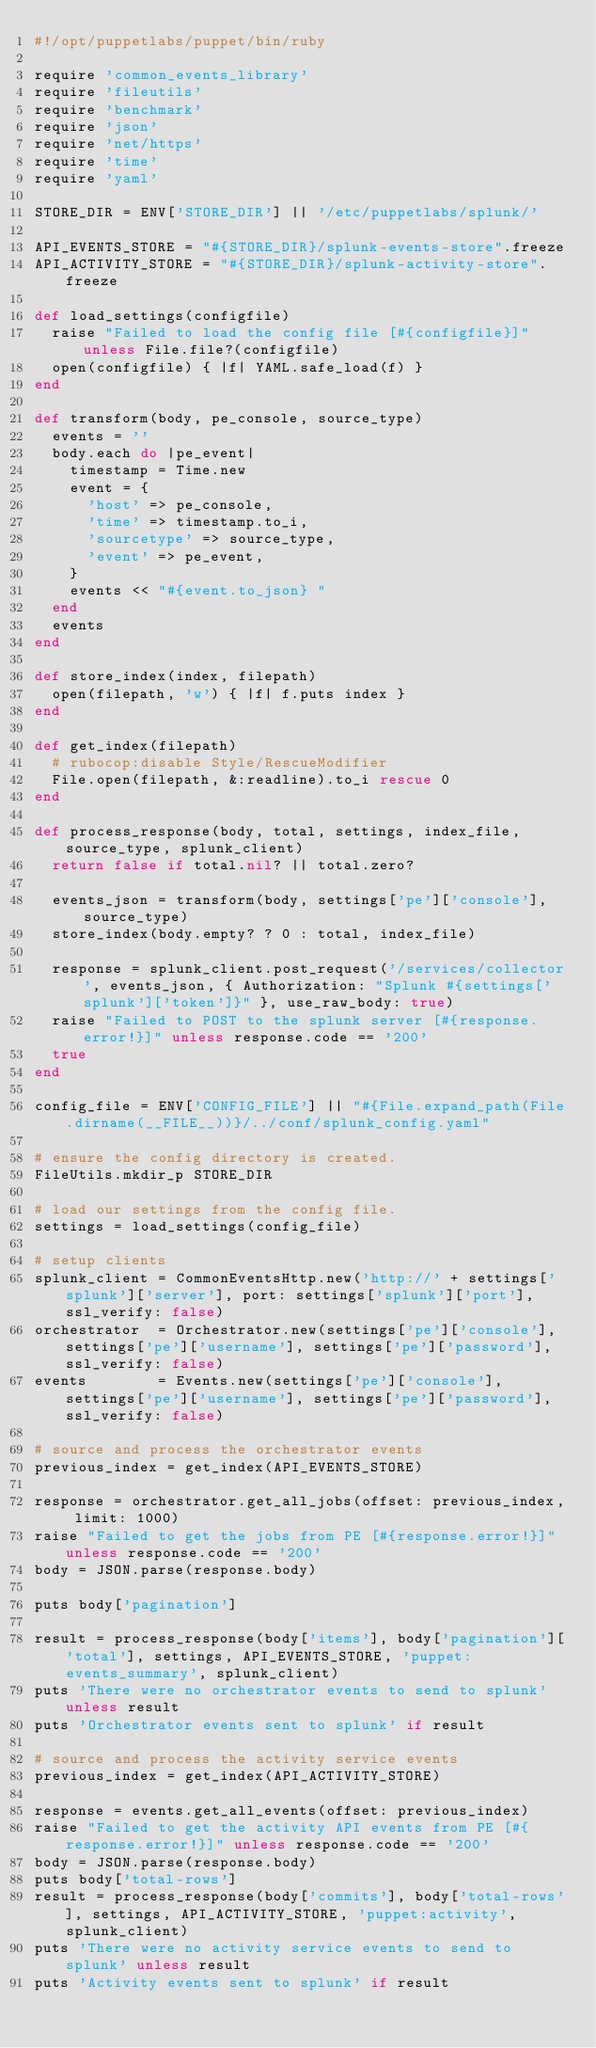<code> <loc_0><loc_0><loc_500><loc_500><_Ruby_>#!/opt/puppetlabs/puppet/bin/ruby

require 'common_events_library'
require 'fileutils'
require 'benchmark'
require 'json'
require 'net/https'
require 'time'
require 'yaml'

STORE_DIR = ENV['STORE_DIR'] || '/etc/puppetlabs/splunk/'

API_EVENTS_STORE = "#{STORE_DIR}/splunk-events-store".freeze
API_ACTIVITY_STORE = "#{STORE_DIR}/splunk-activity-store".freeze

def load_settings(configfile)
  raise "Failed to load the config file [#{configfile}]" unless File.file?(configfile)
  open(configfile) { |f| YAML.safe_load(f) }
end

def transform(body, pe_console, source_type)
  events = ''
  body.each do |pe_event|
    timestamp = Time.new
    event = {
      'host' => pe_console,
      'time' => timestamp.to_i,
      'sourcetype' => source_type,
      'event' => pe_event,
    }
    events << "#{event.to_json} "
  end
  events
end

def store_index(index, filepath)
  open(filepath, 'w') { |f| f.puts index }
end

def get_index(filepath)
  # rubocop:disable Style/RescueModifier
  File.open(filepath, &:readline).to_i rescue 0
end

def process_response(body, total, settings, index_file, source_type, splunk_client)
  return false if total.nil? || total.zero?

  events_json = transform(body, settings['pe']['console'], source_type)
  store_index(body.empty? ? 0 : total, index_file)

  response = splunk_client.post_request('/services/collector', events_json, { Authorization: "Splunk #{settings['splunk']['token']}" }, use_raw_body: true)
  raise "Failed to POST to the splunk server [#{response.error!}]" unless response.code == '200'
  true
end

config_file = ENV['CONFIG_FILE'] || "#{File.expand_path(File.dirname(__FILE__))}/../conf/splunk_config.yaml"

# ensure the config directory is created.
FileUtils.mkdir_p STORE_DIR

# load our settings from the config file.
settings = load_settings(config_file)

# setup clients
splunk_client = CommonEventsHttp.new('http://' + settings['splunk']['server'], port: settings['splunk']['port'], ssl_verify: false)
orchestrator  = Orchestrator.new(settings['pe']['console'], settings['pe']['username'], settings['pe']['password'], ssl_verify: false)
events        = Events.new(settings['pe']['console'], settings['pe']['username'], settings['pe']['password'], ssl_verify: false)

# source and process the orchestrator events
previous_index = get_index(API_EVENTS_STORE)

response = orchestrator.get_all_jobs(offset: previous_index, limit: 1000)
raise "Failed to get the jobs from PE [#{response.error!}]" unless response.code == '200'
body = JSON.parse(response.body)

puts body['pagination']

result = process_response(body['items'], body['pagination']['total'], settings, API_EVENTS_STORE, 'puppet:events_summary', splunk_client)
puts 'There were no orchestrator events to send to splunk' unless result
puts 'Orchestrator events sent to splunk' if result

# source and process the activity service events
previous_index = get_index(API_ACTIVITY_STORE)

response = events.get_all_events(offset: previous_index)
raise "Failed to get the activity API events from PE [#{response.error!}]" unless response.code == '200'
body = JSON.parse(response.body)
puts body['total-rows']
result = process_response(body['commits'], body['total-rows'], settings, API_ACTIVITY_STORE, 'puppet:activity', splunk_client)
puts 'There were no activity service events to send to splunk' unless result
puts 'Activity events sent to splunk' if result
</code> 